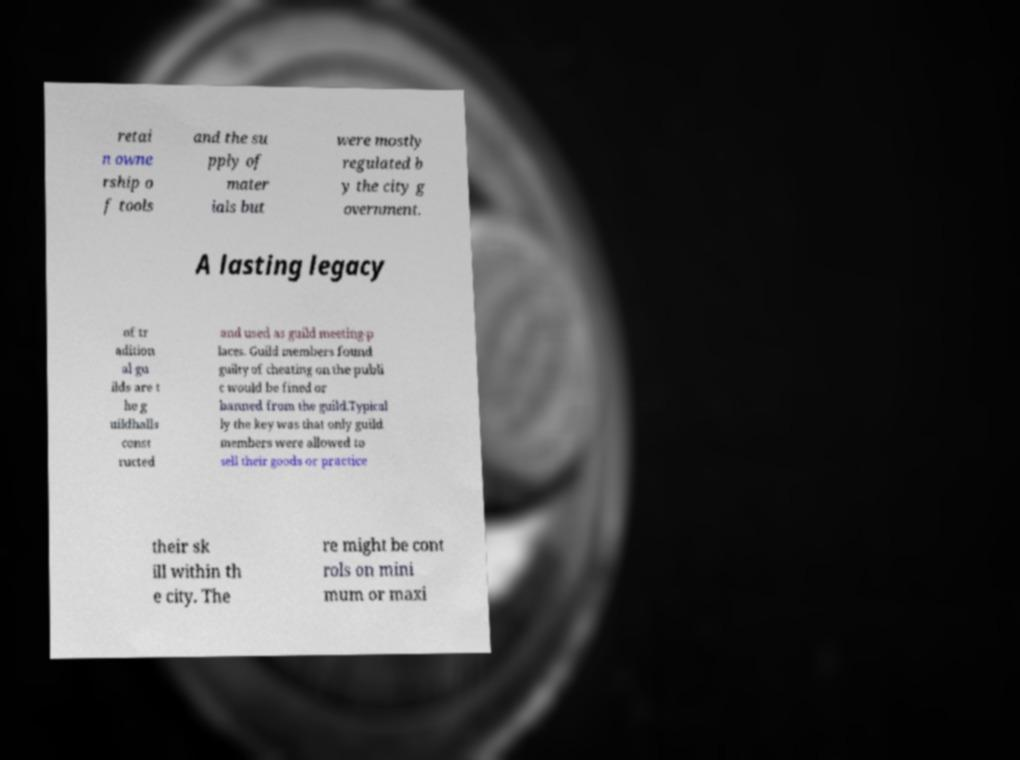Please identify and transcribe the text found in this image. retai n owne rship o f tools and the su pply of mater ials but were mostly regulated b y the city g overnment. A lasting legacy of tr adition al gu ilds are t he g uildhalls const ructed and used as guild meeting-p laces. Guild members found guilty of cheating on the publi c would be fined or banned from the guild.Typical ly the key was that only guild members were allowed to sell their goods or practice their sk ill within th e city. The re might be cont rols on mini mum or maxi 